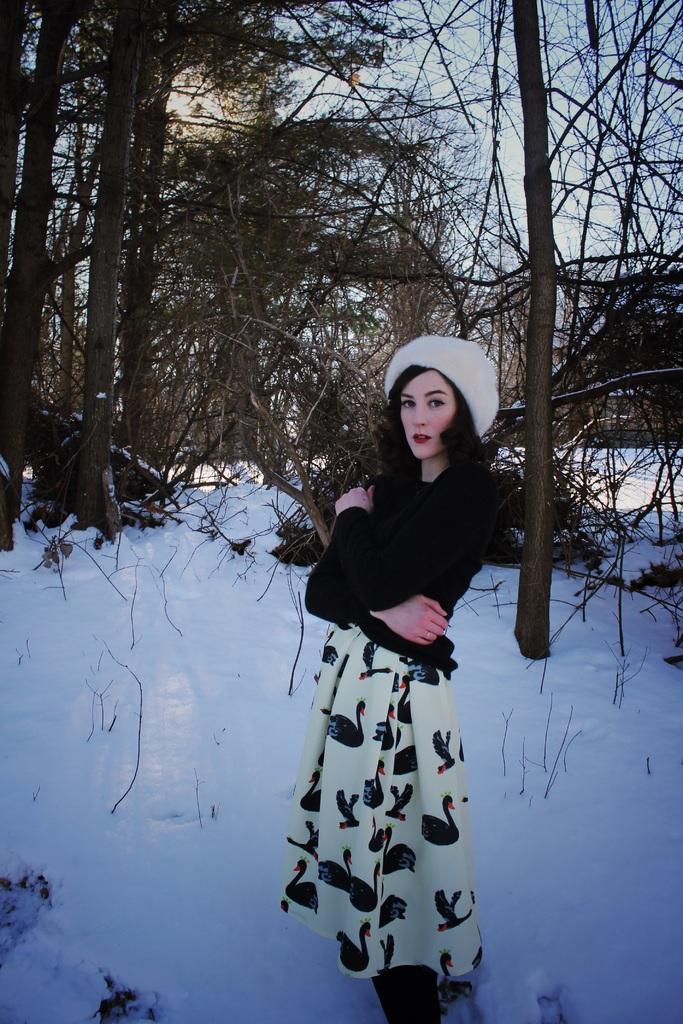Could you give a brief overview of what you see in this image? In this image I can see a person standing and wearing black and white dress and a white color cap. Back I can see few dry trees and snow. The sky is in blue and white color. 